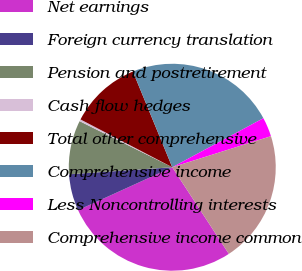Convert chart. <chart><loc_0><loc_0><loc_500><loc_500><pie_chart><fcel>Net earnings<fcel>Foreign currency translation<fcel>Pension and postretirement<fcel>Cash flow hedges<fcel>Total other comprehensive<fcel>Comprehensive income<fcel>Less Noncontrolling interests<fcel>Comprehensive income common<nl><fcel>27.41%<fcel>5.72%<fcel>8.43%<fcel>0.3%<fcel>11.14%<fcel>23.35%<fcel>3.01%<fcel>20.64%<nl></chart> 